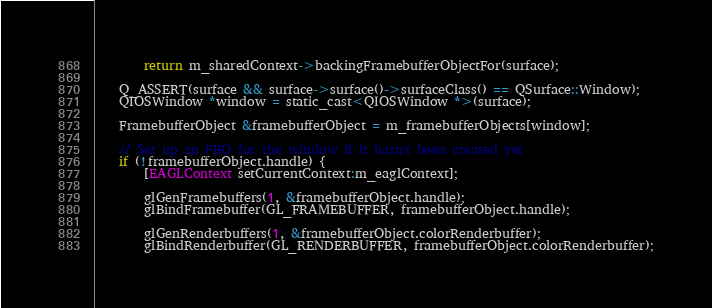<code> <loc_0><loc_0><loc_500><loc_500><_ObjectiveC_>        return m_sharedContext->backingFramebufferObjectFor(surface);

    Q_ASSERT(surface && surface->surface()->surfaceClass() == QSurface::Window);
    QIOSWindow *window = static_cast<QIOSWindow *>(surface);

    FramebufferObject &framebufferObject = m_framebufferObjects[window];

    // Set up an FBO for the window if it hasn't been created yet
    if (!framebufferObject.handle) {
        [EAGLContext setCurrentContext:m_eaglContext];

        glGenFramebuffers(1, &framebufferObject.handle);
        glBindFramebuffer(GL_FRAMEBUFFER, framebufferObject.handle);

        glGenRenderbuffers(1, &framebufferObject.colorRenderbuffer);
        glBindRenderbuffer(GL_RENDERBUFFER, framebufferObject.colorRenderbuffer);</code> 